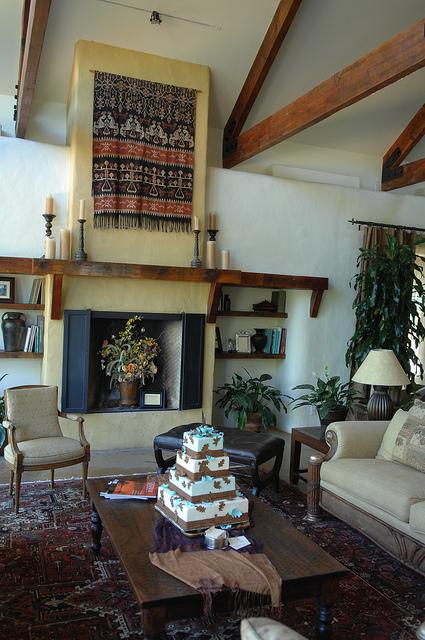What room in a house is this?
Concise answer only. Living room. What color is the carpet?
Give a very brief answer. Red. Is that a wedding cake on the table?
Write a very short answer. Yes. How are the cakes decorated?
Write a very short answer. Frosting. What color best describes the pillows on the couches?
Keep it brief. Beige. What color is the rug?
Be succinct. Red. Is the couch the same color as the chairs?
Answer briefly. Yes. How many candles are on the mantle?
Keep it brief. 8. How many layers are on the cake?
Give a very brief answer. 4. 